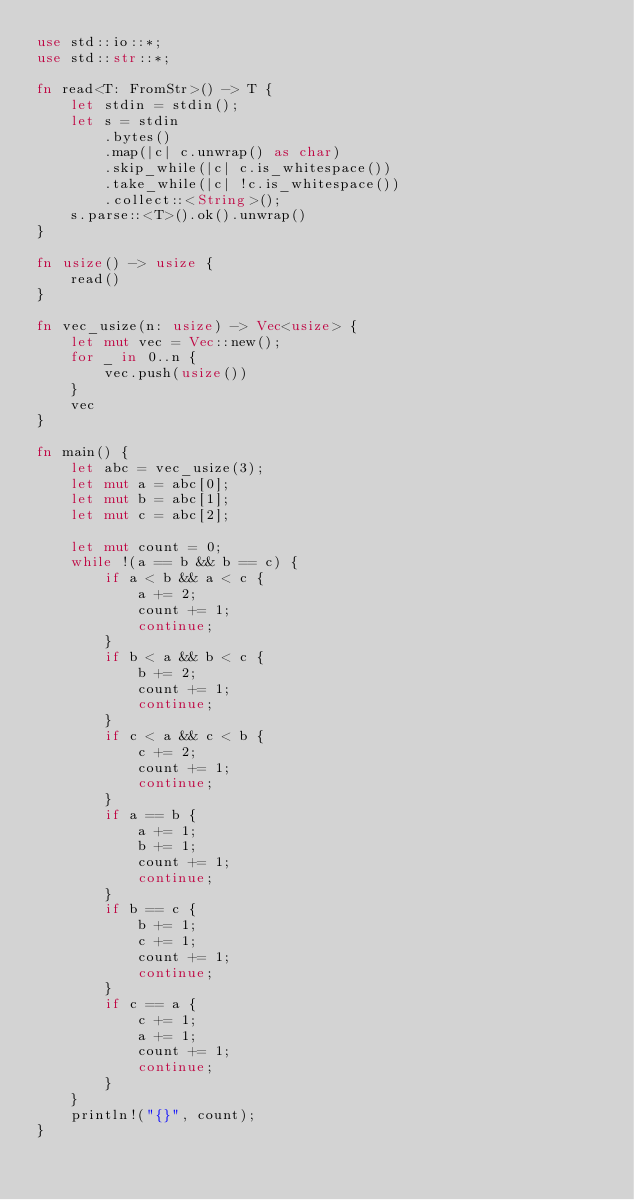Convert code to text. <code><loc_0><loc_0><loc_500><loc_500><_Rust_>use std::io::*;
use std::str::*;

fn read<T: FromStr>() -> T {
    let stdin = stdin();
    let s = stdin
        .bytes()
        .map(|c| c.unwrap() as char)
        .skip_while(|c| c.is_whitespace())
        .take_while(|c| !c.is_whitespace())
        .collect::<String>();
    s.parse::<T>().ok().unwrap()
}

fn usize() -> usize {
    read()
}

fn vec_usize(n: usize) -> Vec<usize> {
    let mut vec = Vec::new();
    for _ in 0..n {
        vec.push(usize())
    }
    vec
}

fn main() {
    let abc = vec_usize(3);
    let mut a = abc[0];
    let mut b = abc[1];
    let mut c = abc[2];

    let mut count = 0;
    while !(a == b && b == c) {
        if a < b && a < c {
            a += 2;
            count += 1;
            continue;
        }
        if b < a && b < c {
            b += 2;
            count += 1;
            continue;
        }
        if c < a && c < b {
            c += 2;
            count += 1;
            continue;
        }
        if a == b {
            a += 1;
            b += 1;
            count += 1;
            continue;
        }
        if b == c {
            b += 1;
            c += 1;
            count += 1;
            continue;
        }
        if c == a {
            c += 1;
            a += 1;
            count += 1;
            continue;
        }
    }
    println!("{}", count);
}
</code> 